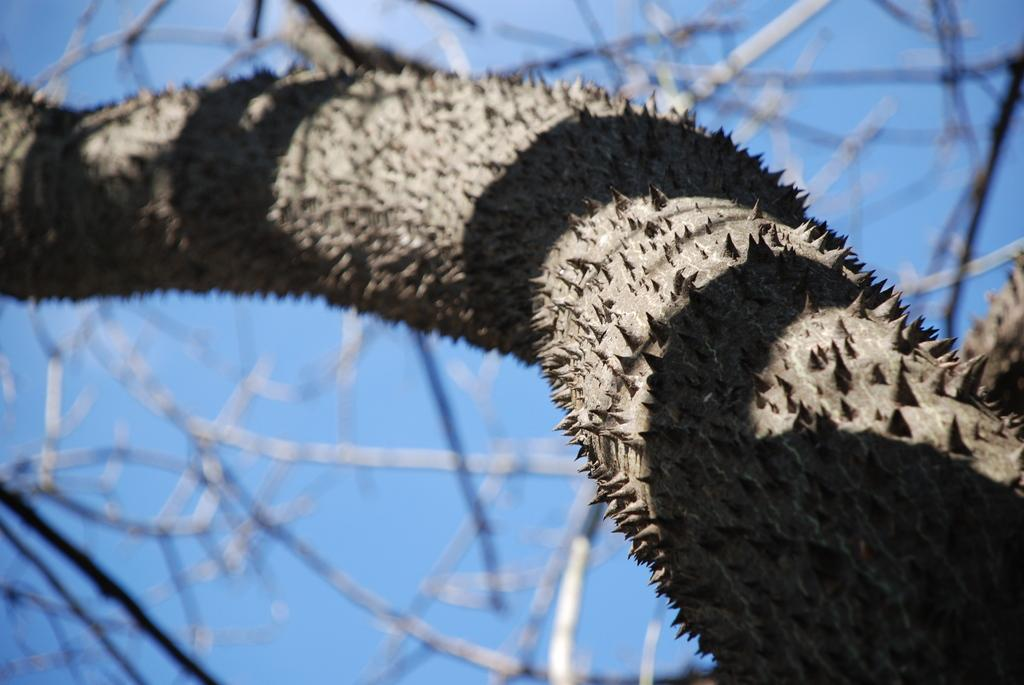What type of vegetation is present in the image? There is a tree in the image. What else can be seen in the image besides the tree? The sky is visible in the image. What is the color of the sky in the image? The sky is blue in color. How many oranges are hanging from the tree in the image? There are no oranges present in the image; it only features a tree and the blue sky. What word is written on the tree in the image? There are no words written on the tree in the image. 